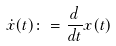<formula> <loc_0><loc_0><loc_500><loc_500>\dot { x } ( t ) \colon = \frac { d } { d t } x ( t )</formula> 